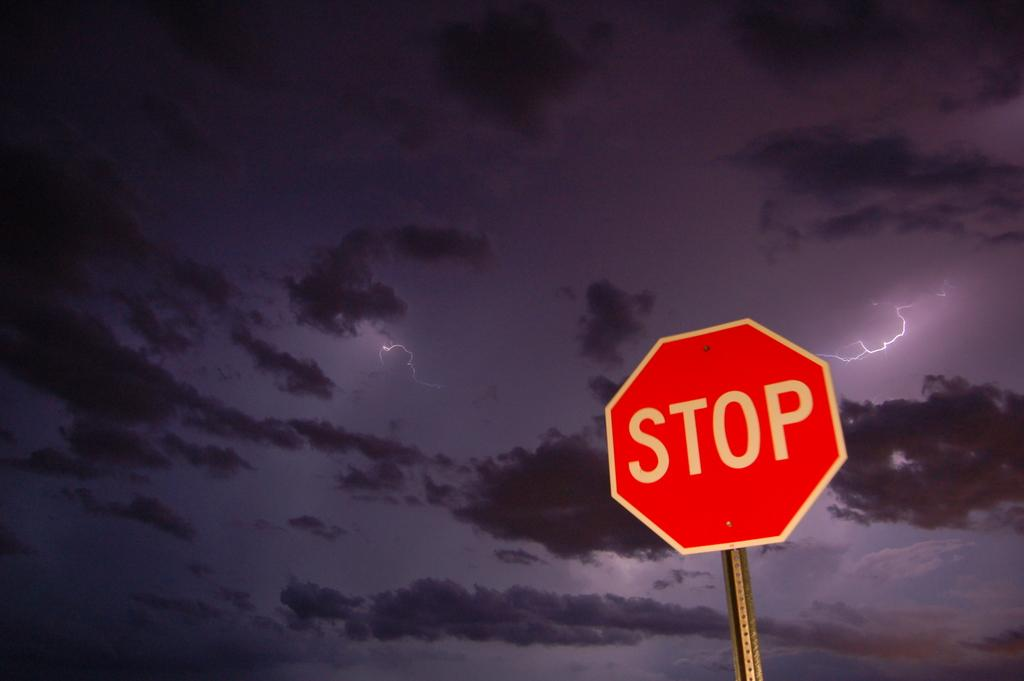<image>
Give a short and clear explanation of the subsequent image. A stop sign against the background of a dark and stormy sky. 